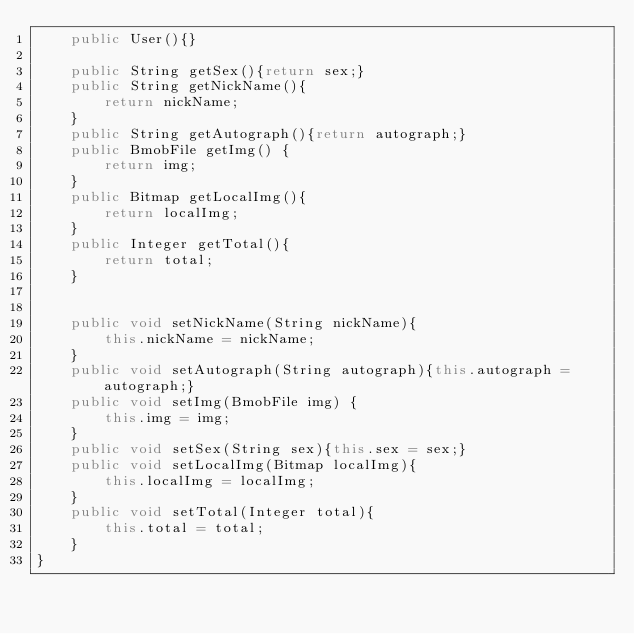<code> <loc_0><loc_0><loc_500><loc_500><_Java_>    public User(){}

    public String getSex(){return sex;}
    public String getNickName(){
        return nickName;
    }
    public String getAutograph(){return autograph;}
    public BmobFile getImg() {
        return img;
    }
    public Bitmap getLocalImg(){
        return localImg;
    }
    public Integer getTotal(){
        return total;
    }


    public void setNickName(String nickName){
        this.nickName = nickName;
    }
    public void setAutograph(String autograph){this.autograph = autograph;}
    public void setImg(BmobFile img) {
        this.img = img;
    }
    public void setSex(String sex){this.sex = sex;}
    public void setLocalImg(Bitmap localImg){
        this.localImg = localImg;
    }
    public void setTotal(Integer total){
        this.total = total;
    }
}
</code> 